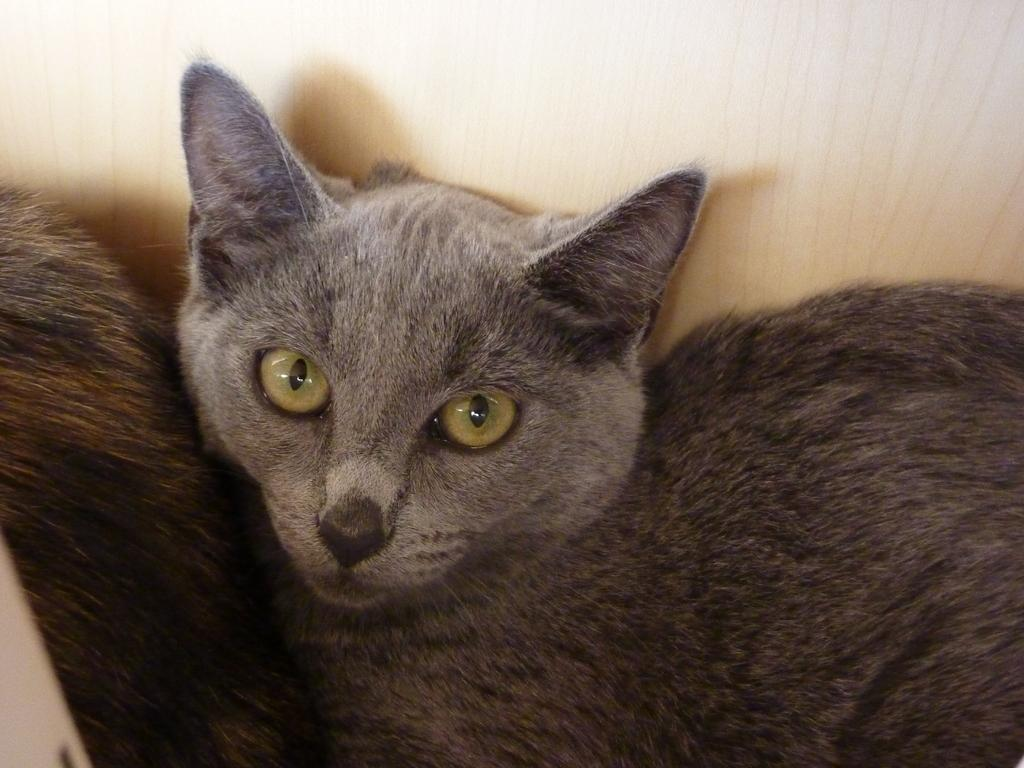How many cats are present in the image? There are two cats in the image. What type of receipt can be seen in the image? There is no receipt present in the image; it only features two cats. What shape is the chin of the cat on the left? The image does not provide enough detail to determine the shape of the chin of the cat on the left. 